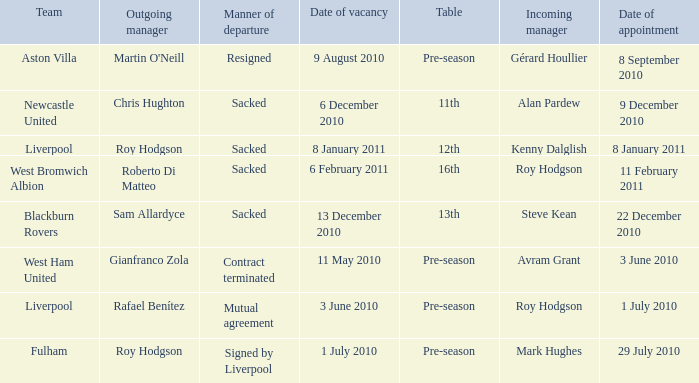What team has an incoming manager named Kenny Dalglish? Liverpool. 